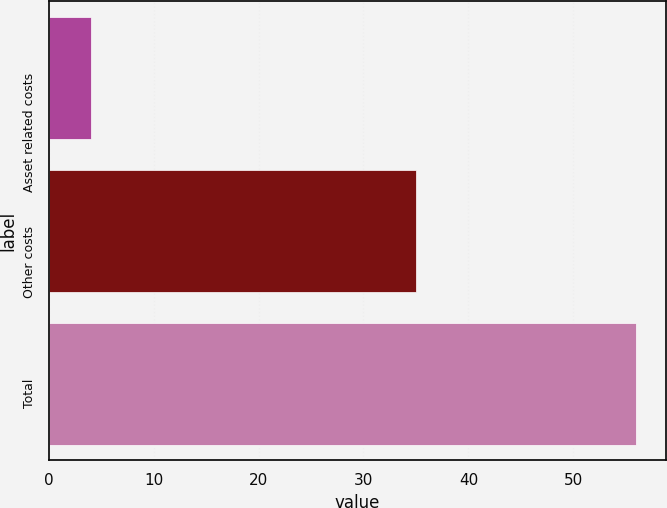Convert chart to OTSL. <chart><loc_0><loc_0><loc_500><loc_500><bar_chart><fcel>Asset related costs<fcel>Other costs<fcel>Total<nl><fcel>4<fcel>35<fcel>56<nl></chart> 